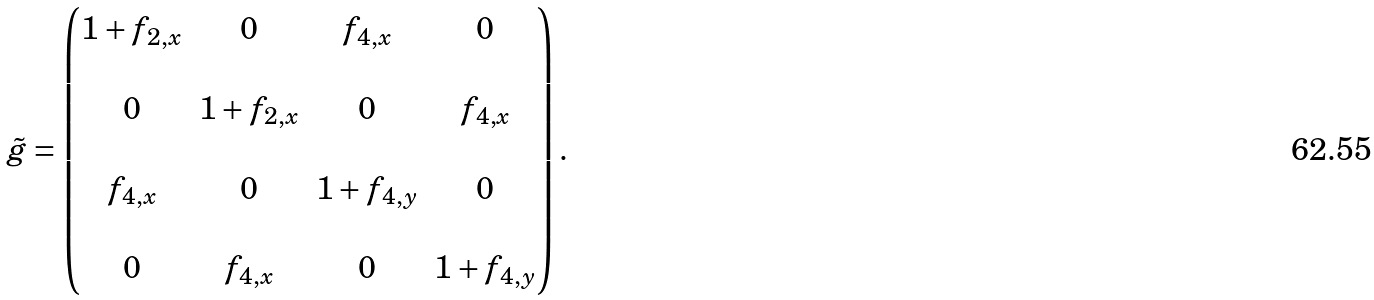Convert formula to latex. <formula><loc_0><loc_0><loc_500><loc_500>\tilde { g } = \begin{pmatrix} 1 + f _ { 2 , x } & 0 & f _ { 4 , x } & 0 \\ & & & \\ 0 & 1 + f _ { 2 , x } & 0 & f _ { 4 , x } \\ & & & \\ f _ { 4 , x } & 0 & 1 + f _ { 4 , y } & 0 \\ & & & \\ 0 & f _ { 4 , x } & 0 & 1 + f _ { 4 , y } \end{pmatrix} .</formula> 